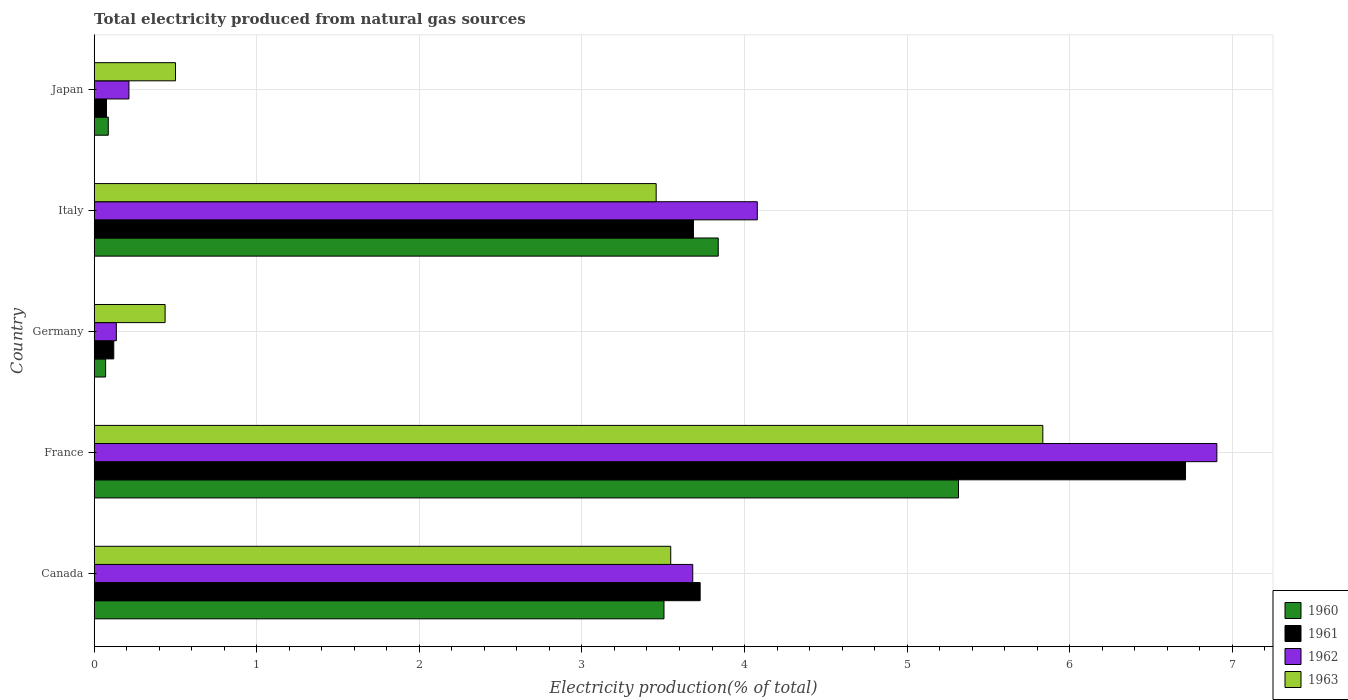How many different coloured bars are there?
Offer a terse response. 4. Are the number of bars per tick equal to the number of legend labels?
Offer a terse response. Yes. What is the total electricity produced in 1961 in Italy?
Provide a short and direct response. 3.69. Across all countries, what is the maximum total electricity produced in 1961?
Ensure brevity in your answer.  6.71. Across all countries, what is the minimum total electricity produced in 1961?
Make the answer very short. 0.08. In which country was the total electricity produced in 1962 maximum?
Ensure brevity in your answer.  France. In which country was the total electricity produced in 1962 minimum?
Offer a very short reply. Germany. What is the total total electricity produced in 1961 in the graph?
Ensure brevity in your answer.  14.32. What is the difference between the total electricity produced in 1963 in Italy and that in Japan?
Offer a very short reply. 2.96. What is the difference between the total electricity produced in 1963 in Italy and the total electricity produced in 1960 in Germany?
Your answer should be compact. 3.39. What is the average total electricity produced in 1961 per country?
Keep it short and to the point. 2.86. What is the difference between the total electricity produced in 1960 and total electricity produced in 1963 in Japan?
Give a very brief answer. -0.41. What is the ratio of the total electricity produced in 1961 in Italy to that in Japan?
Your answer should be compact. 48.69. Is the difference between the total electricity produced in 1960 in Canada and Germany greater than the difference between the total electricity produced in 1963 in Canada and Germany?
Your answer should be compact. Yes. What is the difference between the highest and the second highest total electricity produced in 1960?
Make the answer very short. 1.48. What is the difference between the highest and the lowest total electricity produced in 1960?
Provide a short and direct response. 5.25. In how many countries, is the total electricity produced in 1960 greater than the average total electricity produced in 1960 taken over all countries?
Keep it short and to the point. 3. Is it the case that in every country, the sum of the total electricity produced in 1963 and total electricity produced in 1961 is greater than the sum of total electricity produced in 1960 and total electricity produced in 1962?
Provide a succinct answer. No. What does the 1st bar from the top in Canada represents?
Keep it short and to the point. 1963. Is it the case that in every country, the sum of the total electricity produced in 1962 and total electricity produced in 1963 is greater than the total electricity produced in 1961?
Offer a terse response. Yes. How many bars are there?
Your response must be concise. 20. What is the difference between two consecutive major ticks on the X-axis?
Provide a short and direct response. 1. Are the values on the major ticks of X-axis written in scientific E-notation?
Your response must be concise. No. Does the graph contain any zero values?
Make the answer very short. No. Where does the legend appear in the graph?
Make the answer very short. Bottom right. How many legend labels are there?
Your response must be concise. 4. How are the legend labels stacked?
Offer a very short reply. Vertical. What is the title of the graph?
Make the answer very short. Total electricity produced from natural gas sources. What is the label or title of the Y-axis?
Offer a terse response. Country. What is the Electricity production(% of total) in 1960 in Canada?
Provide a succinct answer. 3.5. What is the Electricity production(% of total) of 1961 in Canada?
Offer a terse response. 3.73. What is the Electricity production(% of total) in 1962 in Canada?
Provide a succinct answer. 3.68. What is the Electricity production(% of total) of 1963 in Canada?
Keep it short and to the point. 3.55. What is the Electricity production(% of total) in 1960 in France?
Your answer should be compact. 5.32. What is the Electricity production(% of total) in 1961 in France?
Ensure brevity in your answer.  6.71. What is the Electricity production(% of total) in 1962 in France?
Give a very brief answer. 6.91. What is the Electricity production(% of total) of 1963 in France?
Give a very brief answer. 5.83. What is the Electricity production(% of total) of 1960 in Germany?
Provide a short and direct response. 0.07. What is the Electricity production(% of total) in 1961 in Germany?
Give a very brief answer. 0.12. What is the Electricity production(% of total) of 1962 in Germany?
Your answer should be very brief. 0.14. What is the Electricity production(% of total) in 1963 in Germany?
Ensure brevity in your answer.  0.44. What is the Electricity production(% of total) of 1960 in Italy?
Provide a succinct answer. 3.84. What is the Electricity production(% of total) in 1961 in Italy?
Offer a very short reply. 3.69. What is the Electricity production(% of total) of 1962 in Italy?
Make the answer very short. 4.08. What is the Electricity production(% of total) of 1963 in Italy?
Your answer should be compact. 3.46. What is the Electricity production(% of total) of 1960 in Japan?
Provide a short and direct response. 0.09. What is the Electricity production(% of total) in 1961 in Japan?
Your response must be concise. 0.08. What is the Electricity production(% of total) of 1962 in Japan?
Give a very brief answer. 0.21. What is the Electricity production(% of total) in 1963 in Japan?
Make the answer very short. 0.5. Across all countries, what is the maximum Electricity production(% of total) of 1960?
Your answer should be compact. 5.32. Across all countries, what is the maximum Electricity production(% of total) in 1961?
Your answer should be very brief. 6.71. Across all countries, what is the maximum Electricity production(% of total) of 1962?
Offer a very short reply. 6.91. Across all countries, what is the maximum Electricity production(% of total) in 1963?
Give a very brief answer. 5.83. Across all countries, what is the minimum Electricity production(% of total) of 1960?
Offer a very short reply. 0.07. Across all countries, what is the minimum Electricity production(% of total) of 1961?
Offer a terse response. 0.08. Across all countries, what is the minimum Electricity production(% of total) in 1962?
Give a very brief answer. 0.14. Across all countries, what is the minimum Electricity production(% of total) of 1963?
Ensure brevity in your answer.  0.44. What is the total Electricity production(% of total) in 1960 in the graph?
Give a very brief answer. 12.82. What is the total Electricity production(% of total) in 1961 in the graph?
Ensure brevity in your answer.  14.32. What is the total Electricity production(% of total) in 1962 in the graph?
Your answer should be compact. 15.01. What is the total Electricity production(% of total) in 1963 in the graph?
Provide a short and direct response. 13.77. What is the difference between the Electricity production(% of total) in 1960 in Canada and that in France?
Give a very brief answer. -1.81. What is the difference between the Electricity production(% of total) in 1961 in Canada and that in France?
Offer a terse response. -2.99. What is the difference between the Electricity production(% of total) of 1962 in Canada and that in France?
Offer a terse response. -3.22. What is the difference between the Electricity production(% of total) in 1963 in Canada and that in France?
Ensure brevity in your answer.  -2.29. What is the difference between the Electricity production(% of total) in 1960 in Canada and that in Germany?
Make the answer very short. 3.43. What is the difference between the Electricity production(% of total) in 1961 in Canada and that in Germany?
Keep it short and to the point. 3.61. What is the difference between the Electricity production(% of total) in 1962 in Canada and that in Germany?
Offer a terse response. 3.55. What is the difference between the Electricity production(% of total) of 1963 in Canada and that in Germany?
Provide a short and direct response. 3.11. What is the difference between the Electricity production(% of total) of 1960 in Canada and that in Italy?
Keep it short and to the point. -0.33. What is the difference between the Electricity production(% of total) of 1961 in Canada and that in Italy?
Ensure brevity in your answer.  0.04. What is the difference between the Electricity production(% of total) in 1962 in Canada and that in Italy?
Provide a succinct answer. -0.4. What is the difference between the Electricity production(% of total) in 1963 in Canada and that in Italy?
Offer a terse response. 0.09. What is the difference between the Electricity production(% of total) in 1960 in Canada and that in Japan?
Make the answer very short. 3.42. What is the difference between the Electricity production(% of total) of 1961 in Canada and that in Japan?
Offer a very short reply. 3.65. What is the difference between the Electricity production(% of total) in 1962 in Canada and that in Japan?
Give a very brief answer. 3.47. What is the difference between the Electricity production(% of total) in 1963 in Canada and that in Japan?
Your response must be concise. 3.05. What is the difference between the Electricity production(% of total) in 1960 in France and that in Germany?
Provide a succinct answer. 5.25. What is the difference between the Electricity production(% of total) of 1961 in France and that in Germany?
Give a very brief answer. 6.59. What is the difference between the Electricity production(% of total) in 1962 in France and that in Germany?
Give a very brief answer. 6.77. What is the difference between the Electricity production(% of total) of 1963 in France and that in Germany?
Offer a very short reply. 5.4. What is the difference between the Electricity production(% of total) in 1960 in France and that in Italy?
Your answer should be very brief. 1.48. What is the difference between the Electricity production(% of total) of 1961 in France and that in Italy?
Ensure brevity in your answer.  3.03. What is the difference between the Electricity production(% of total) in 1962 in France and that in Italy?
Your answer should be very brief. 2.83. What is the difference between the Electricity production(% of total) of 1963 in France and that in Italy?
Keep it short and to the point. 2.38. What is the difference between the Electricity production(% of total) in 1960 in France and that in Japan?
Provide a succinct answer. 5.23. What is the difference between the Electricity production(% of total) of 1961 in France and that in Japan?
Make the answer very short. 6.64. What is the difference between the Electricity production(% of total) in 1962 in France and that in Japan?
Offer a very short reply. 6.69. What is the difference between the Electricity production(% of total) in 1963 in France and that in Japan?
Provide a short and direct response. 5.33. What is the difference between the Electricity production(% of total) of 1960 in Germany and that in Italy?
Your response must be concise. -3.77. What is the difference between the Electricity production(% of total) of 1961 in Germany and that in Italy?
Offer a terse response. -3.57. What is the difference between the Electricity production(% of total) of 1962 in Germany and that in Italy?
Keep it short and to the point. -3.94. What is the difference between the Electricity production(% of total) in 1963 in Germany and that in Italy?
Offer a terse response. -3.02. What is the difference between the Electricity production(% of total) in 1960 in Germany and that in Japan?
Offer a very short reply. -0.02. What is the difference between the Electricity production(% of total) in 1961 in Germany and that in Japan?
Provide a succinct answer. 0.04. What is the difference between the Electricity production(% of total) of 1962 in Germany and that in Japan?
Give a very brief answer. -0.08. What is the difference between the Electricity production(% of total) in 1963 in Germany and that in Japan?
Provide a short and direct response. -0.06. What is the difference between the Electricity production(% of total) of 1960 in Italy and that in Japan?
Give a very brief answer. 3.75. What is the difference between the Electricity production(% of total) of 1961 in Italy and that in Japan?
Your answer should be compact. 3.61. What is the difference between the Electricity production(% of total) of 1962 in Italy and that in Japan?
Make the answer very short. 3.86. What is the difference between the Electricity production(% of total) in 1963 in Italy and that in Japan?
Your answer should be compact. 2.96. What is the difference between the Electricity production(% of total) in 1960 in Canada and the Electricity production(% of total) in 1961 in France?
Provide a succinct answer. -3.21. What is the difference between the Electricity production(% of total) in 1960 in Canada and the Electricity production(% of total) in 1962 in France?
Your answer should be compact. -3.4. What is the difference between the Electricity production(% of total) of 1960 in Canada and the Electricity production(% of total) of 1963 in France?
Provide a short and direct response. -2.33. What is the difference between the Electricity production(% of total) in 1961 in Canada and the Electricity production(% of total) in 1962 in France?
Provide a succinct answer. -3.18. What is the difference between the Electricity production(% of total) of 1961 in Canada and the Electricity production(% of total) of 1963 in France?
Offer a terse response. -2.11. What is the difference between the Electricity production(% of total) in 1962 in Canada and the Electricity production(% of total) in 1963 in France?
Your answer should be compact. -2.15. What is the difference between the Electricity production(% of total) in 1960 in Canada and the Electricity production(% of total) in 1961 in Germany?
Your answer should be compact. 3.38. What is the difference between the Electricity production(% of total) of 1960 in Canada and the Electricity production(% of total) of 1962 in Germany?
Ensure brevity in your answer.  3.37. What is the difference between the Electricity production(% of total) in 1960 in Canada and the Electricity production(% of total) in 1963 in Germany?
Keep it short and to the point. 3.07. What is the difference between the Electricity production(% of total) in 1961 in Canada and the Electricity production(% of total) in 1962 in Germany?
Provide a succinct answer. 3.59. What is the difference between the Electricity production(% of total) of 1961 in Canada and the Electricity production(% of total) of 1963 in Germany?
Your answer should be compact. 3.29. What is the difference between the Electricity production(% of total) of 1962 in Canada and the Electricity production(% of total) of 1963 in Germany?
Ensure brevity in your answer.  3.25. What is the difference between the Electricity production(% of total) of 1960 in Canada and the Electricity production(% of total) of 1961 in Italy?
Provide a short and direct response. -0.18. What is the difference between the Electricity production(% of total) of 1960 in Canada and the Electricity production(% of total) of 1962 in Italy?
Provide a succinct answer. -0.57. What is the difference between the Electricity production(% of total) of 1960 in Canada and the Electricity production(% of total) of 1963 in Italy?
Offer a terse response. 0.05. What is the difference between the Electricity production(% of total) in 1961 in Canada and the Electricity production(% of total) in 1962 in Italy?
Your response must be concise. -0.35. What is the difference between the Electricity production(% of total) in 1961 in Canada and the Electricity production(% of total) in 1963 in Italy?
Keep it short and to the point. 0.27. What is the difference between the Electricity production(% of total) of 1962 in Canada and the Electricity production(% of total) of 1963 in Italy?
Offer a very short reply. 0.23. What is the difference between the Electricity production(% of total) of 1960 in Canada and the Electricity production(% of total) of 1961 in Japan?
Your answer should be very brief. 3.43. What is the difference between the Electricity production(% of total) in 1960 in Canada and the Electricity production(% of total) in 1962 in Japan?
Your response must be concise. 3.29. What is the difference between the Electricity production(% of total) in 1960 in Canada and the Electricity production(% of total) in 1963 in Japan?
Provide a short and direct response. 3. What is the difference between the Electricity production(% of total) in 1961 in Canada and the Electricity production(% of total) in 1962 in Japan?
Your response must be concise. 3.51. What is the difference between the Electricity production(% of total) in 1961 in Canada and the Electricity production(% of total) in 1963 in Japan?
Make the answer very short. 3.23. What is the difference between the Electricity production(% of total) of 1962 in Canada and the Electricity production(% of total) of 1963 in Japan?
Give a very brief answer. 3.18. What is the difference between the Electricity production(% of total) of 1960 in France and the Electricity production(% of total) of 1961 in Germany?
Your answer should be very brief. 5.2. What is the difference between the Electricity production(% of total) in 1960 in France and the Electricity production(% of total) in 1962 in Germany?
Keep it short and to the point. 5.18. What is the difference between the Electricity production(% of total) in 1960 in France and the Electricity production(% of total) in 1963 in Germany?
Your response must be concise. 4.88. What is the difference between the Electricity production(% of total) in 1961 in France and the Electricity production(% of total) in 1962 in Germany?
Ensure brevity in your answer.  6.58. What is the difference between the Electricity production(% of total) of 1961 in France and the Electricity production(% of total) of 1963 in Germany?
Your answer should be compact. 6.28. What is the difference between the Electricity production(% of total) of 1962 in France and the Electricity production(% of total) of 1963 in Germany?
Provide a succinct answer. 6.47. What is the difference between the Electricity production(% of total) of 1960 in France and the Electricity production(% of total) of 1961 in Italy?
Make the answer very short. 1.63. What is the difference between the Electricity production(% of total) of 1960 in France and the Electricity production(% of total) of 1962 in Italy?
Provide a short and direct response. 1.24. What is the difference between the Electricity production(% of total) of 1960 in France and the Electricity production(% of total) of 1963 in Italy?
Your answer should be compact. 1.86. What is the difference between the Electricity production(% of total) in 1961 in France and the Electricity production(% of total) in 1962 in Italy?
Keep it short and to the point. 2.63. What is the difference between the Electricity production(% of total) of 1961 in France and the Electricity production(% of total) of 1963 in Italy?
Your response must be concise. 3.26. What is the difference between the Electricity production(% of total) of 1962 in France and the Electricity production(% of total) of 1963 in Italy?
Provide a short and direct response. 3.45. What is the difference between the Electricity production(% of total) of 1960 in France and the Electricity production(% of total) of 1961 in Japan?
Your response must be concise. 5.24. What is the difference between the Electricity production(% of total) of 1960 in France and the Electricity production(% of total) of 1962 in Japan?
Ensure brevity in your answer.  5.1. What is the difference between the Electricity production(% of total) in 1960 in France and the Electricity production(% of total) in 1963 in Japan?
Ensure brevity in your answer.  4.82. What is the difference between the Electricity production(% of total) in 1961 in France and the Electricity production(% of total) in 1962 in Japan?
Offer a terse response. 6.5. What is the difference between the Electricity production(% of total) of 1961 in France and the Electricity production(% of total) of 1963 in Japan?
Offer a very short reply. 6.21. What is the difference between the Electricity production(% of total) in 1962 in France and the Electricity production(% of total) in 1963 in Japan?
Keep it short and to the point. 6.4. What is the difference between the Electricity production(% of total) in 1960 in Germany and the Electricity production(% of total) in 1961 in Italy?
Offer a very short reply. -3.62. What is the difference between the Electricity production(% of total) of 1960 in Germany and the Electricity production(% of total) of 1962 in Italy?
Your answer should be very brief. -4.01. What is the difference between the Electricity production(% of total) of 1960 in Germany and the Electricity production(% of total) of 1963 in Italy?
Your response must be concise. -3.39. What is the difference between the Electricity production(% of total) in 1961 in Germany and the Electricity production(% of total) in 1962 in Italy?
Your answer should be compact. -3.96. What is the difference between the Electricity production(% of total) of 1961 in Germany and the Electricity production(% of total) of 1963 in Italy?
Ensure brevity in your answer.  -3.34. What is the difference between the Electricity production(% of total) in 1962 in Germany and the Electricity production(% of total) in 1963 in Italy?
Offer a very short reply. -3.32. What is the difference between the Electricity production(% of total) of 1960 in Germany and the Electricity production(% of total) of 1961 in Japan?
Your answer should be very brief. -0.01. What is the difference between the Electricity production(% of total) of 1960 in Germany and the Electricity production(% of total) of 1962 in Japan?
Offer a very short reply. -0.14. What is the difference between the Electricity production(% of total) of 1960 in Germany and the Electricity production(% of total) of 1963 in Japan?
Ensure brevity in your answer.  -0.43. What is the difference between the Electricity production(% of total) in 1961 in Germany and the Electricity production(% of total) in 1962 in Japan?
Make the answer very short. -0.09. What is the difference between the Electricity production(% of total) in 1961 in Germany and the Electricity production(% of total) in 1963 in Japan?
Ensure brevity in your answer.  -0.38. What is the difference between the Electricity production(% of total) of 1962 in Germany and the Electricity production(% of total) of 1963 in Japan?
Your answer should be very brief. -0.36. What is the difference between the Electricity production(% of total) of 1960 in Italy and the Electricity production(% of total) of 1961 in Japan?
Provide a short and direct response. 3.76. What is the difference between the Electricity production(% of total) of 1960 in Italy and the Electricity production(% of total) of 1962 in Japan?
Your answer should be compact. 3.62. What is the difference between the Electricity production(% of total) of 1960 in Italy and the Electricity production(% of total) of 1963 in Japan?
Offer a very short reply. 3.34. What is the difference between the Electricity production(% of total) in 1961 in Italy and the Electricity production(% of total) in 1962 in Japan?
Your answer should be compact. 3.47. What is the difference between the Electricity production(% of total) in 1961 in Italy and the Electricity production(% of total) in 1963 in Japan?
Your answer should be compact. 3.19. What is the difference between the Electricity production(% of total) of 1962 in Italy and the Electricity production(% of total) of 1963 in Japan?
Ensure brevity in your answer.  3.58. What is the average Electricity production(% of total) in 1960 per country?
Provide a short and direct response. 2.56. What is the average Electricity production(% of total) in 1961 per country?
Ensure brevity in your answer.  2.86. What is the average Electricity production(% of total) in 1962 per country?
Your response must be concise. 3. What is the average Electricity production(% of total) in 1963 per country?
Your response must be concise. 2.75. What is the difference between the Electricity production(% of total) in 1960 and Electricity production(% of total) in 1961 in Canada?
Keep it short and to the point. -0.22. What is the difference between the Electricity production(% of total) in 1960 and Electricity production(% of total) in 1962 in Canada?
Offer a very short reply. -0.18. What is the difference between the Electricity production(% of total) of 1960 and Electricity production(% of total) of 1963 in Canada?
Offer a very short reply. -0.04. What is the difference between the Electricity production(% of total) in 1961 and Electricity production(% of total) in 1962 in Canada?
Your answer should be compact. 0.05. What is the difference between the Electricity production(% of total) in 1961 and Electricity production(% of total) in 1963 in Canada?
Your response must be concise. 0.18. What is the difference between the Electricity production(% of total) in 1962 and Electricity production(% of total) in 1963 in Canada?
Give a very brief answer. 0.14. What is the difference between the Electricity production(% of total) of 1960 and Electricity production(% of total) of 1961 in France?
Ensure brevity in your answer.  -1.4. What is the difference between the Electricity production(% of total) in 1960 and Electricity production(% of total) in 1962 in France?
Offer a terse response. -1.59. What is the difference between the Electricity production(% of total) of 1960 and Electricity production(% of total) of 1963 in France?
Provide a short and direct response. -0.52. What is the difference between the Electricity production(% of total) in 1961 and Electricity production(% of total) in 1962 in France?
Give a very brief answer. -0.19. What is the difference between the Electricity production(% of total) of 1961 and Electricity production(% of total) of 1963 in France?
Provide a short and direct response. 0.88. What is the difference between the Electricity production(% of total) in 1962 and Electricity production(% of total) in 1963 in France?
Give a very brief answer. 1.07. What is the difference between the Electricity production(% of total) in 1960 and Electricity production(% of total) in 1962 in Germany?
Give a very brief answer. -0.07. What is the difference between the Electricity production(% of total) in 1960 and Electricity production(% of total) in 1963 in Germany?
Your answer should be very brief. -0.37. What is the difference between the Electricity production(% of total) of 1961 and Electricity production(% of total) of 1962 in Germany?
Offer a very short reply. -0.02. What is the difference between the Electricity production(% of total) of 1961 and Electricity production(% of total) of 1963 in Germany?
Provide a short and direct response. -0.32. What is the difference between the Electricity production(% of total) of 1962 and Electricity production(% of total) of 1963 in Germany?
Offer a very short reply. -0.3. What is the difference between the Electricity production(% of total) of 1960 and Electricity production(% of total) of 1961 in Italy?
Offer a terse response. 0.15. What is the difference between the Electricity production(% of total) of 1960 and Electricity production(% of total) of 1962 in Italy?
Provide a succinct answer. -0.24. What is the difference between the Electricity production(% of total) of 1960 and Electricity production(% of total) of 1963 in Italy?
Ensure brevity in your answer.  0.38. What is the difference between the Electricity production(% of total) in 1961 and Electricity production(% of total) in 1962 in Italy?
Offer a terse response. -0.39. What is the difference between the Electricity production(% of total) of 1961 and Electricity production(% of total) of 1963 in Italy?
Provide a succinct answer. 0.23. What is the difference between the Electricity production(% of total) of 1962 and Electricity production(% of total) of 1963 in Italy?
Ensure brevity in your answer.  0.62. What is the difference between the Electricity production(% of total) of 1960 and Electricity production(% of total) of 1961 in Japan?
Give a very brief answer. 0.01. What is the difference between the Electricity production(% of total) of 1960 and Electricity production(% of total) of 1962 in Japan?
Offer a very short reply. -0.13. What is the difference between the Electricity production(% of total) of 1960 and Electricity production(% of total) of 1963 in Japan?
Make the answer very short. -0.41. What is the difference between the Electricity production(% of total) of 1961 and Electricity production(% of total) of 1962 in Japan?
Make the answer very short. -0.14. What is the difference between the Electricity production(% of total) of 1961 and Electricity production(% of total) of 1963 in Japan?
Keep it short and to the point. -0.42. What is the difference between the Electricity production(% of total) in 1962 and Electricity production(% of total) in 1963 in Japan?
Your response must be concise. -0.29. What is the ratio of the Electricity production(% of total) of 1960 in Canada to that in France?
Your answer should be compact. 0.66. What is the ratio of the Electricity production(% of total) of 1961 in Canada to that in France?
Keep it short and to the point. 0.56. What is the ratio of the Electricity production(% of total) of 1962 in Canada to that in France?
Your answer should be very brief. 0.53. What is the ratio of the Electricity production(% of total) of 1963 in Canada to that in France?
Your response must be concise. 0.61. What is the ratio of the Electricity production(% of total) of 1960 in Canada to that in Germany?
Ensure brevity in your answer.  49.85. What is the ratio of the Electricity production(% of total) of 1961 in Canada to that in Germany?
Make the answer very short. 30.98. What is the ratio of the Electricity production(% of total) of 1962 in Canada to that in Germany?
Offer a very short reply. 27.02. What is the ratio of the Electricity production(% of total) of 1963 in Canada to that in Germany?
Offer a terse response. 8.13. What is the ratio of the Electricity production(% of total) in 1960 in Canada to that in Italy?
Make the answer very short. 0.91. What is the ratio of the Electricity production(% of total) in 1961 in Canada to that in Italy?
Give a very brief answer. 1.01. What is the ratio of the Electricity production(% of total) in 1962 in Canada to that in Italy?
Your answer should be very brief. 0.9. What is the ratio of the Electricity production(% of total) of 1963 in Canada to that in Italy?
Offer a very short reply. 1.03. What is the ratio of the Electricity production(% of total) of 1960 in Canada to that in Japan?
Provide a short and direct response. 40.48. What is the ratio of the Electricity production(% of total) in 1961 in Canada to that in Japan?
Make the answer very short. 49.23. What is the ratio of the Electricity production(% of total) of 1962 in Canada to that in Japan?
Ensure brevity in your answer.  17.23. What is the ratio of the Electricity production(% of total) in 1963 in Canada to that in Japan?
Offer a very short reply. 7.09. What is the ratio of the Electricity production(% of total) in 1960 in France to that in Germany?
Provide a succinct answer. 75.62. What is the ratio of the Electricity production(% of total) in 1961 in France to that in Germany?
Provide a short and direct response. 55.79. What is the ratio of the Electricity production(% of total) of 1962 in France to that in Germany?
Your answer should be very brief. 50.69. What is the ratio of the Electricity production(% of total) in 1963 in France to that in Germany?
Your response must be concise. 13.38. What is the ratio of the Electricity production(% of total) of 1960 in France to that in Italy?
Your answer should be very brief. 1.39. What is the ratio of the Electricity production(% of total) in 1961 in France to that in Italy?
Ensure brevity in your answer.  1.82. What is the ratio of the Electricity production(% of total) of 1962 in France to that in Italy?
Your response must be concise. 1.69. What is the ratio of the Electricity production(% of total) in 1963 in France to that in Italy?
Make the answer very short. 1.69. What is the ratio of the Electricity production(% of total) of 1960 in France to that in Japan?
Keep it short and to the point. 61.4. What is the ratio of the Electricity production(% of total) of 1961 in France to that in Japan?
Give a very brief answer. 88.67. What is the ratio of the Electricity production(% of total) of 1962 in France to that in Japan?
Offer a very short reply. 32.32. What is the ratio of the Electricity production(% of total) of 1963 in France to that in Japan?
Provide a succinct answer. 11.67. What is the ratio of the Electricity production(% of total) of 1960 in Germany to that in Italy?
Make the answer very short. 0.02. What is the ratio of the Electricity production(% of total) in 1961 in Germany to that in Italy?
Your response must be concise. 0.03. What is the ratio of the Electricity production(% of total) in 1962 in Germany to that in Italy?
Your response must be concise. 0.03. What is the ratio of the Electricity production(% of total) in 1963 in Germany to that in Italy?
Ensure brevity in your answer.  0.13. What is the ratio of the Electricity production(% of total) of 1960 in Germany to that in Japan?
Give a very brief answer. 0.81. What is the ratio of the Electricity production(% of total) of 1961 in Germany to that in Japan?
Your answer should be compact. 1.59. What is the ratio of the Electricity production(% of total) of 1962 in Germany to that in Japan?
Your answer should be compact. 0.64. What is the ratio of the Electricity production(% of total) of 1963 in Germany to that in Japan?
Provide a succinct answer. 0.87. What is the ratio of the Electricity production(% of total) in 1960 in Italy to that in Japan?
Your response must be concise. 44.33. What is the ratio of the Electricity production(% of total) in 1961 in Italy to that in Japan?
Your answer should be compact. 48.69. What is the ratio of the Electricity production(% of total) of 1962 in Italy to that in Japan?
Keep it short and to the point. 19.09. What is the ratio of the Electricity production(% of total) in 1963 in Italy to that in Japan?
Provide a succinct answer. 6.91. What is the difference between the highest and the second highest Electricity production(% of total) of 1960?
Keep it short and to the point. 1.48. What is the difference between the highest and the second highest Electricity production(% of total) in 1961?
Ensure brevity in your answer.  2.99. What is the difference between the highest and the second highest Electricity production(% of total) of 1962?
Ensure brevity in your answer.  2.83. What is the difference between the highest and the second highest Electricity production(% of total) in 1963?
Give a very brief answer. 2.29. What is the difference between the highest and the lowest Electricity production(% of total) in 1960?
Your response must be concise. 5.25. What is the difference between the highest and the lowest Electricity production(% of total) in 1961?
Provide a succinct answer. 6.64. What is the difference between the highest and the lowest Electricity production(% of total) of 1962?
Offer a terse response. 6.77. What is the difference between the highest and the lowest Electricity production(% of total) of 1963?
Your answer should be compact. 5.4. 